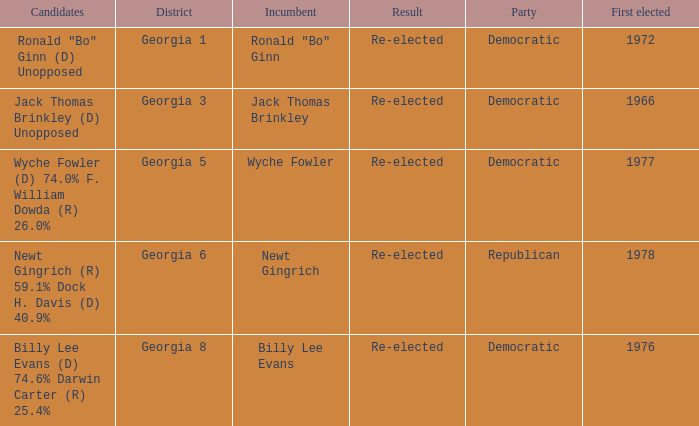When was the first election held for district 1 in georgia? 1972.0. 